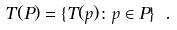Convert formula to latex. <formula><loc_0><loc_0><loc_500><loc_500>T ( P ) = \{ T ( p ) \colon p \in P \} \ .</formula> 